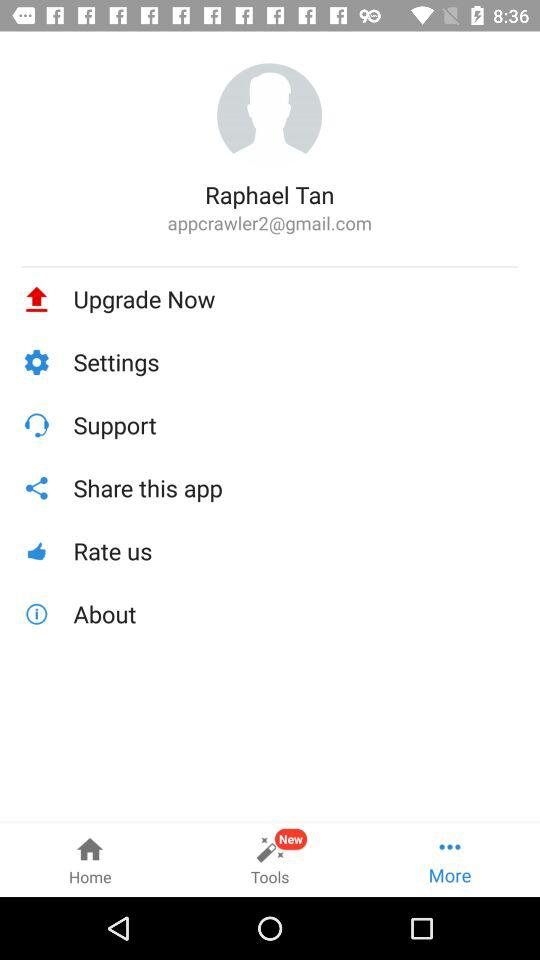What tab is selected? The selected tab is "More". 